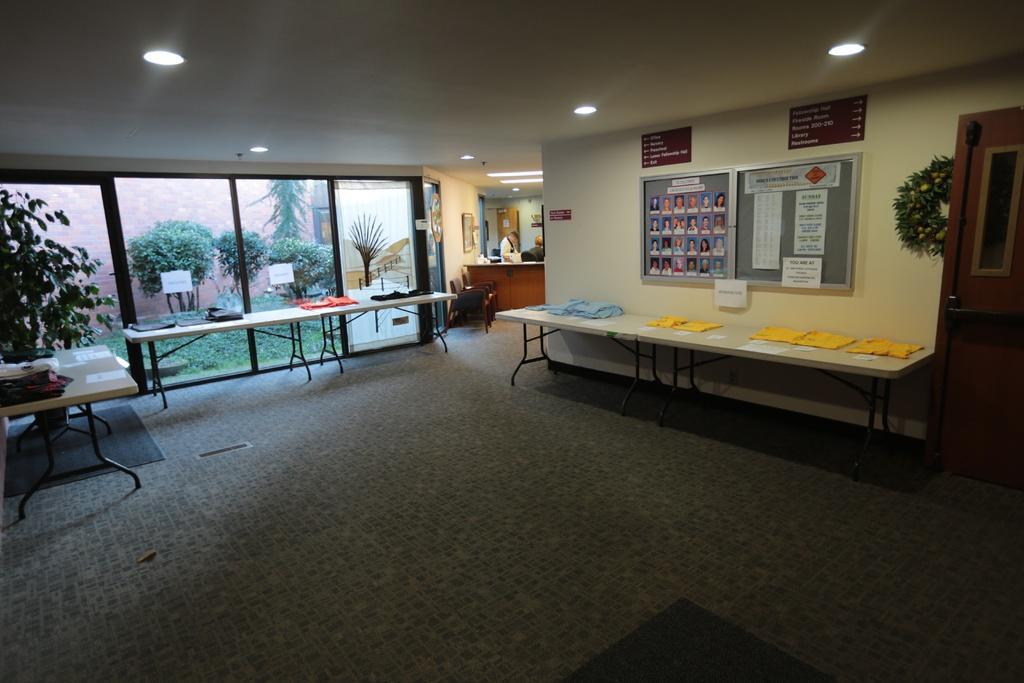In one or two sentences, can you explain what this image depicts? In this image I can see the floor, few tables which are white in color and on the tables I can see few clothes which are white, yellow, blue, pink and black in color. I can see the glass doors through which I can see the wall and few trees. I can see the ceiling, few lights to the ceiling, few persons standing, the wall, few boards attached to the wall and in the board I can see few photographs and few papers. I can see the door which is brown in color to the right side of the image. 